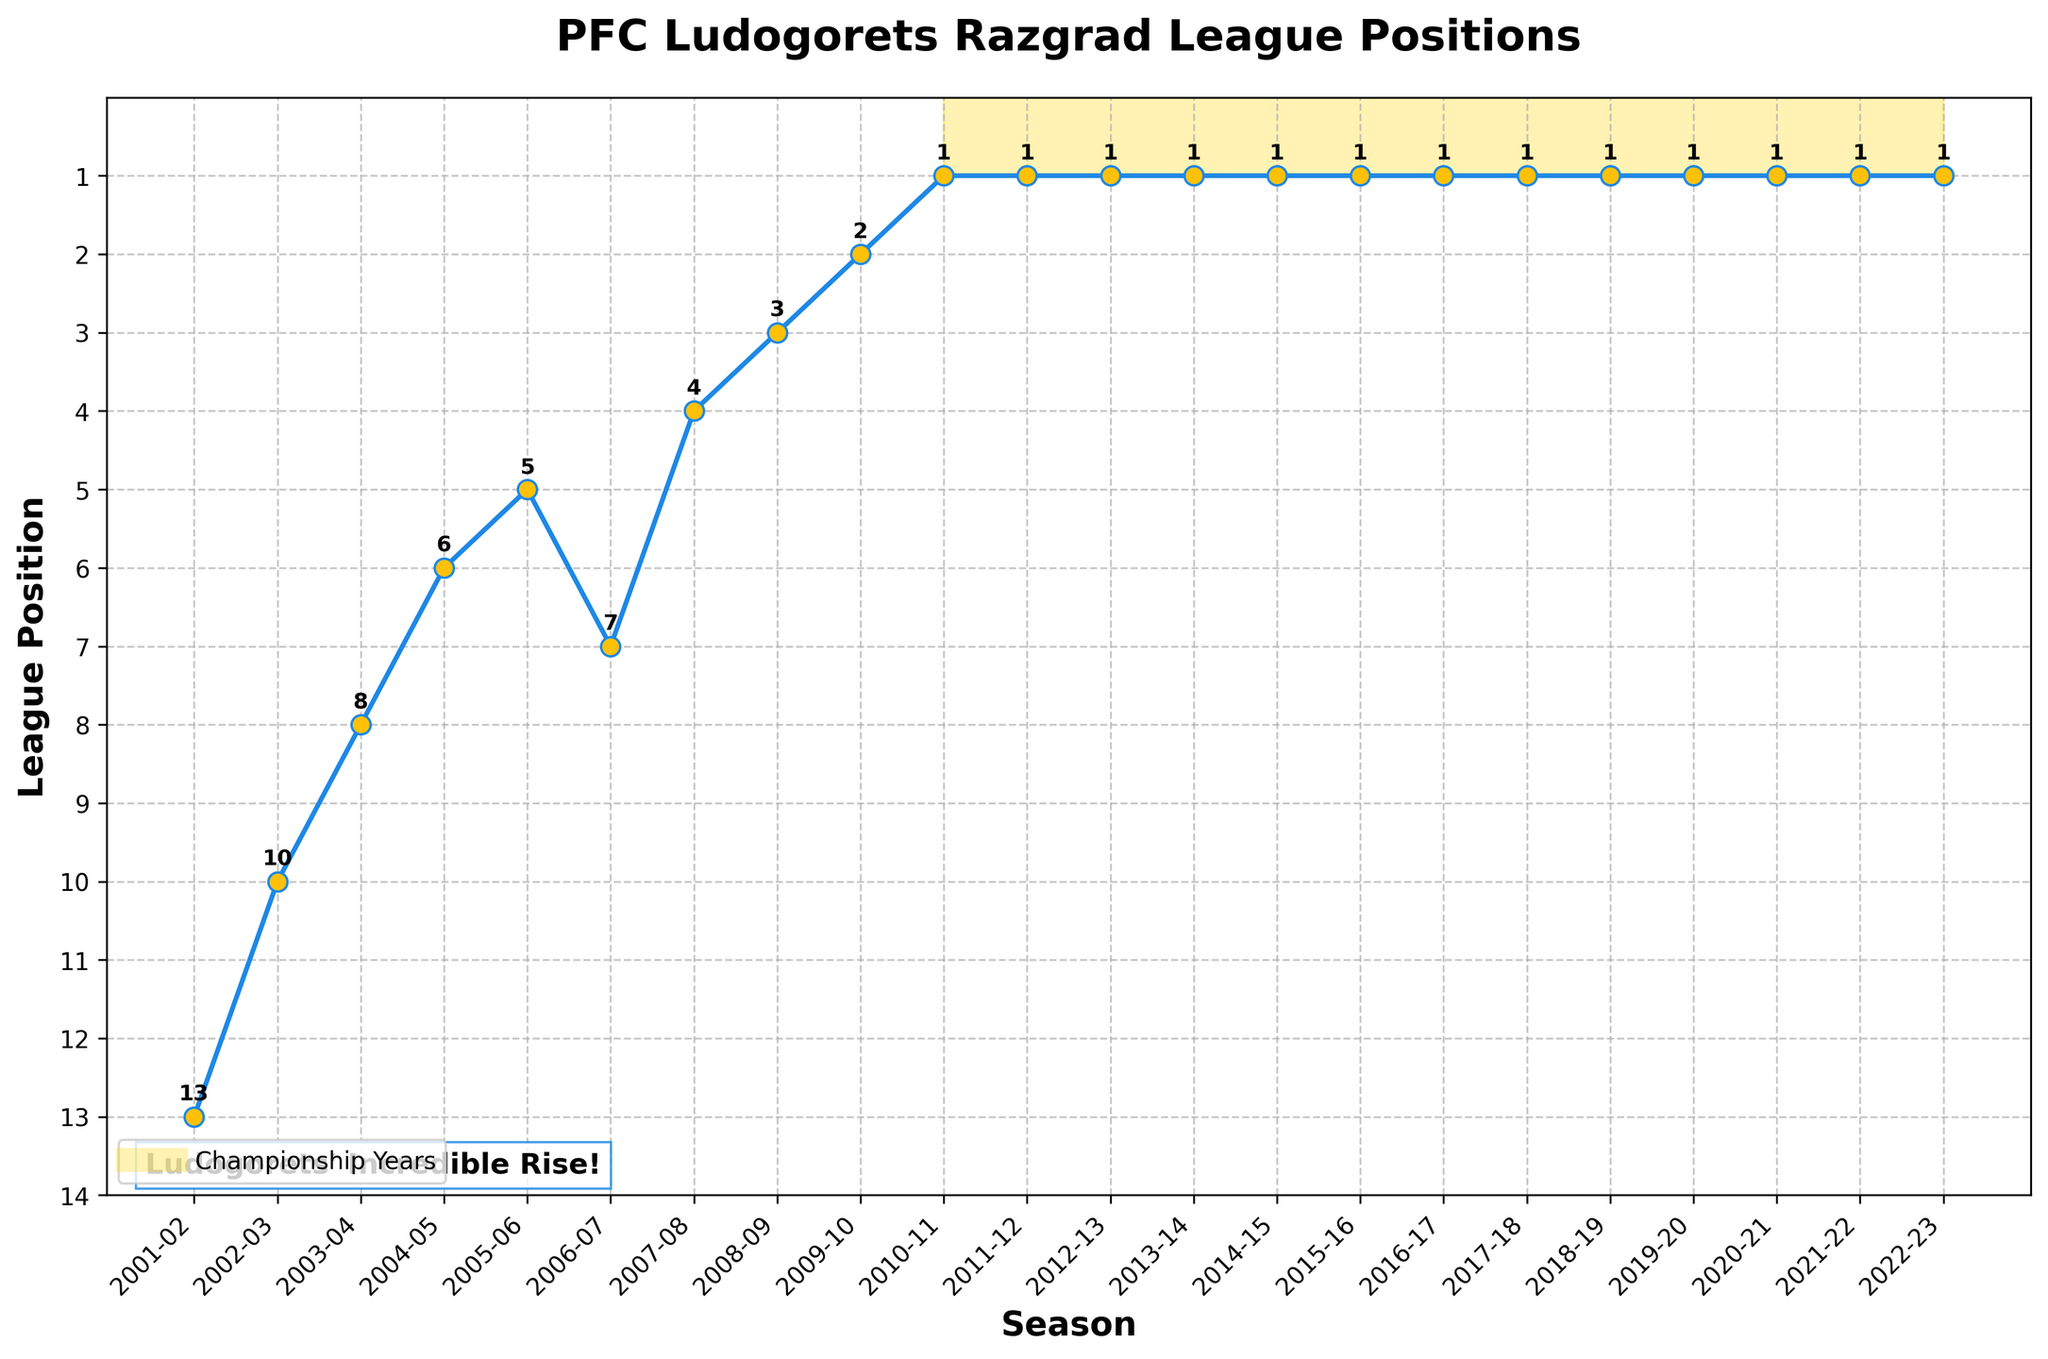How many championship years has Ludogorets had? By visually noting the number of seasons marked with the gold highlight in the plot, you can count the number of championship years. There are 13 instances where the league position is '1'.
Answer: 13 In which season did Ludogorets first reach the top position? Locate the first instance where the league position is '1' on the plot. It occurred in the 2010-11 season.
Answer: 2010-11 What is the trend in Ludogorets' league positions from 2001-02 to 2009-10? Observe the line segment from 2001-02 to 2009-10. The team’s position improved consistently, moving from 13th to 2nd place over these seasons.
Answer: Improved consistently Which season had the sharpest improvement in league position? Compare the differences between each consecutive season's positions. The largest leap is from the 2006-07 (7th) to 2007-08 (4th) season, an improvement of 3 places.
Answer: 2006-07 to 2007-08 Compare the league positions between the 2003-04 season and the 2008-09 season. Which one is better? Look at the league positions for the two seasons. The position in the 2008-09 season (3rd) is better than the position in the 2003-04 season (8th).
Answer: 2008-09 season How many consecutive seasons has Ludogorets been in the top position? Observe the extended period during which the position remains '1'. From the 2011-12 season to the 2022-23 season, Ludogorets consistently held the top position for 12 seasons.
Answer: 12 What's the difference in league position between the 2001-02 season and the 2009-10 season? Calculate the difference between league positions in the 2001-02 (13th) and 2009-10 (2nd) seasons. The difference is 13 - 2 = 11.
Answer: 11 What is the average league position of Ludogorets from 2001-02 to 2009-10? Sum the league positions from 2001-02 to 2009-10 and divide by the number of these seasons. The positions are [13, 10, 8, 6, 5, 7, 4, 3, 2]. Sum = 58. Average = 58/9 = ~6.44
Answer: ~6.44 Which seasons saw Ludogorets finish outside the top 10? Identify seasons where the league position is greater than 10. These are the 2001-02 (13th) and 2002-03 (10th) seasons.
Answer: 2001-02, 2002-03 